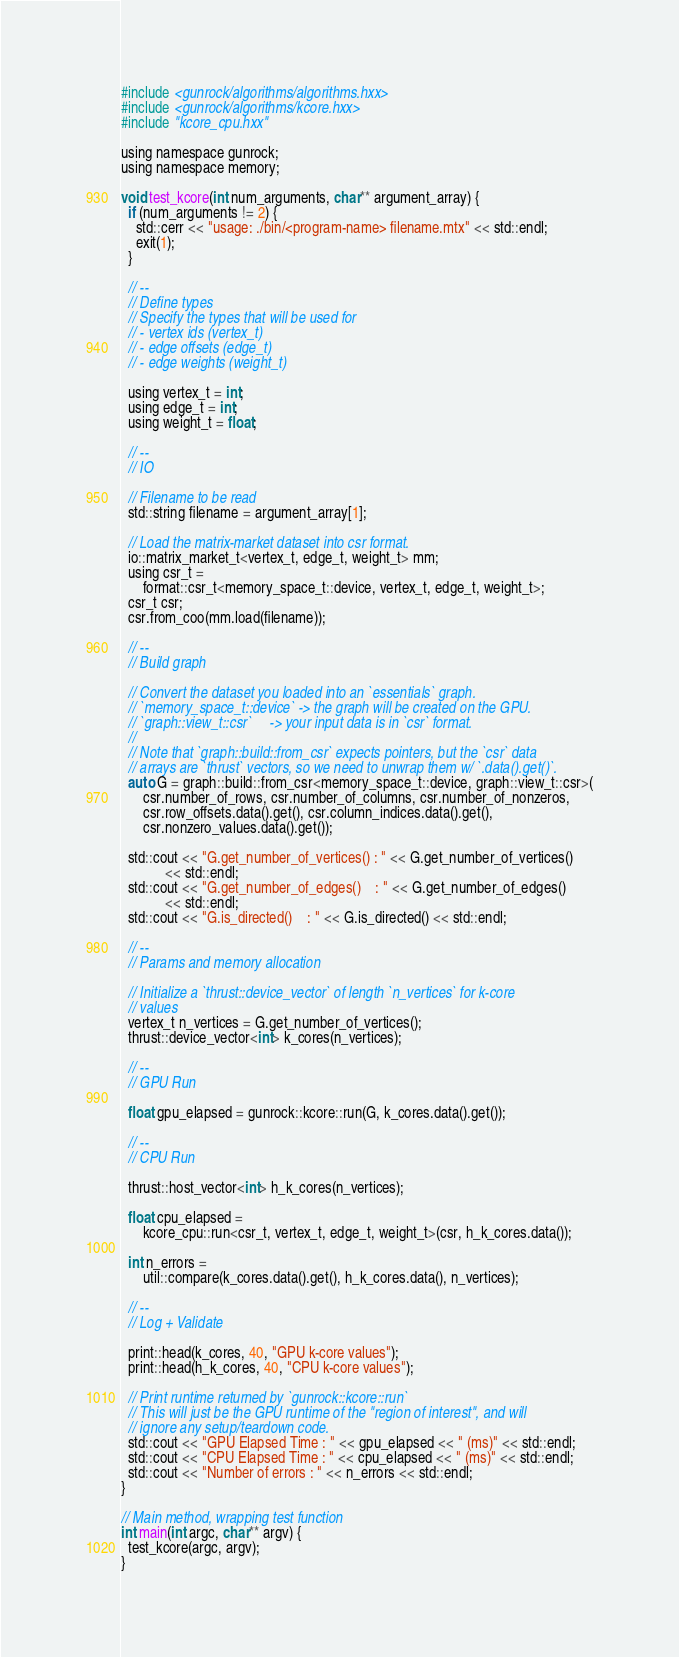<code> <loc_0><loc_0><loc_500><loc_500><_Cuda_>#include <gunrock/algorithms/algorithms.hxx>
#include <gunrock/algorithms/kcore.hxx>
#include "kcore_cpu.hxx"

using namespace gunrock;
using namespace memory;

void test_kcore(int num_arguments, char** argument_array) {
  if (num_arguments != 2) {
    std::cerr << "usage: ./bin/<program-name> filename.mtx" << std::endl;
    exit(1);
  }

  // --
  // Define types
  // Specify the types that will be used for
  // - vertex ids (vertex_t)
  // - edge offsets (edge_t)
  // - edge weights (weight_t)

  using vertex_t = int;
  using edge_t = int;
  using weight_t = float;

  // --
  // IO

  // Filename to be read
  std::string filename = argument_array[1];

  // Load the matrix-market dataset into csr format.
  io::matrix_market_t<vertex_t, edge_t, weight_t> mm;
  using csr_t =
      format::csr_t<memory_space_t::device, vertex_t, edge_t, weight_t>;
  csr_t csr;
  csr.from_coo(mm.load(filename));

  // --
  // Build graph

  // Convert the dataset you loaded into an `essentials` graph.
  // `memory_space_t::device` -> the graph will be created on the GPU.
  // `graph::view_t::csr`     -> your input data is in `csr` format.
  //
  // Note that `graph::build::from_csr` expects pointers, but the `csr` data
  // arrays are `thrust` vectors, so we need to unwrap them w/ `.data().get()`.
  auto G = graph::build::from_csr<memory_space_t::device, graph::view_t::csr>(
      csr.number_of_rows, csr.number_of_columns, csr.number_of_nonzeros,
      csr.row_offsets.data().get(), csr.column_indices.data().get(),
      csr.nonzero_values.data().get());

  std::cout << "G.get_number_of_vertices() : " << G.get_number_of_vertices()
            << std::endl;
  std::cout << "G.get_number_of_edges()    : " << G.get_number_of_edges()
            << std::endl;
  std::cout << "G.is_directed()    : " << G.is_directed() << std::endl;

  // --
  // Params and memory allocation

  // Initialize a `thrust::device_vector` of length `n_vertices` for k-core
  // values
  vertex_t n_vertices = G.get_number_of_vertices();
  thrust::device_vector<int> k_cores(n_vertices);

  // --
  // GPU Run

  float gpu_elapsed = gunrock::kcore::run(G, k_cores.data().get());

  // --
  // CPU Run

  thrust::host_vector<int> h_k_cores(n_vertices);

  float cpu_elapsed =
      kcore_cpu::run<csr_t, vertex_t, edge_t, weight_t>(csr, h_k_cores.data());

  int n_errors =
      util::compare(k_cores.data().get(), h_k_cores.data(), n_vertices);

  // --
  // Log + Validate

  print::head(k_cores, 40, "GPU k-core values");
  print::head(h_k_cores, 40, "CPU k-core values");

  // Print runtime returned by `gunrock::kcore::run`
  // This will just be the GPU runtime of the "region of interest", and will
  // ignore any setup/teardown code.
  std::cout << "GPU Elapsed Time : " << gpu_elapsed << " (ms)" << std::endl;
  std::cout << "CPU Elapsed Time : " << cpu_elapsed << " (ms)" << std::endl;
  std::cout << "Number of errors : " << n_errors << std::endl;
}

// Main method, wrapping test function
int main(int argc, char** argv) {
  test_kcore(argc, argv);
}
</code> 